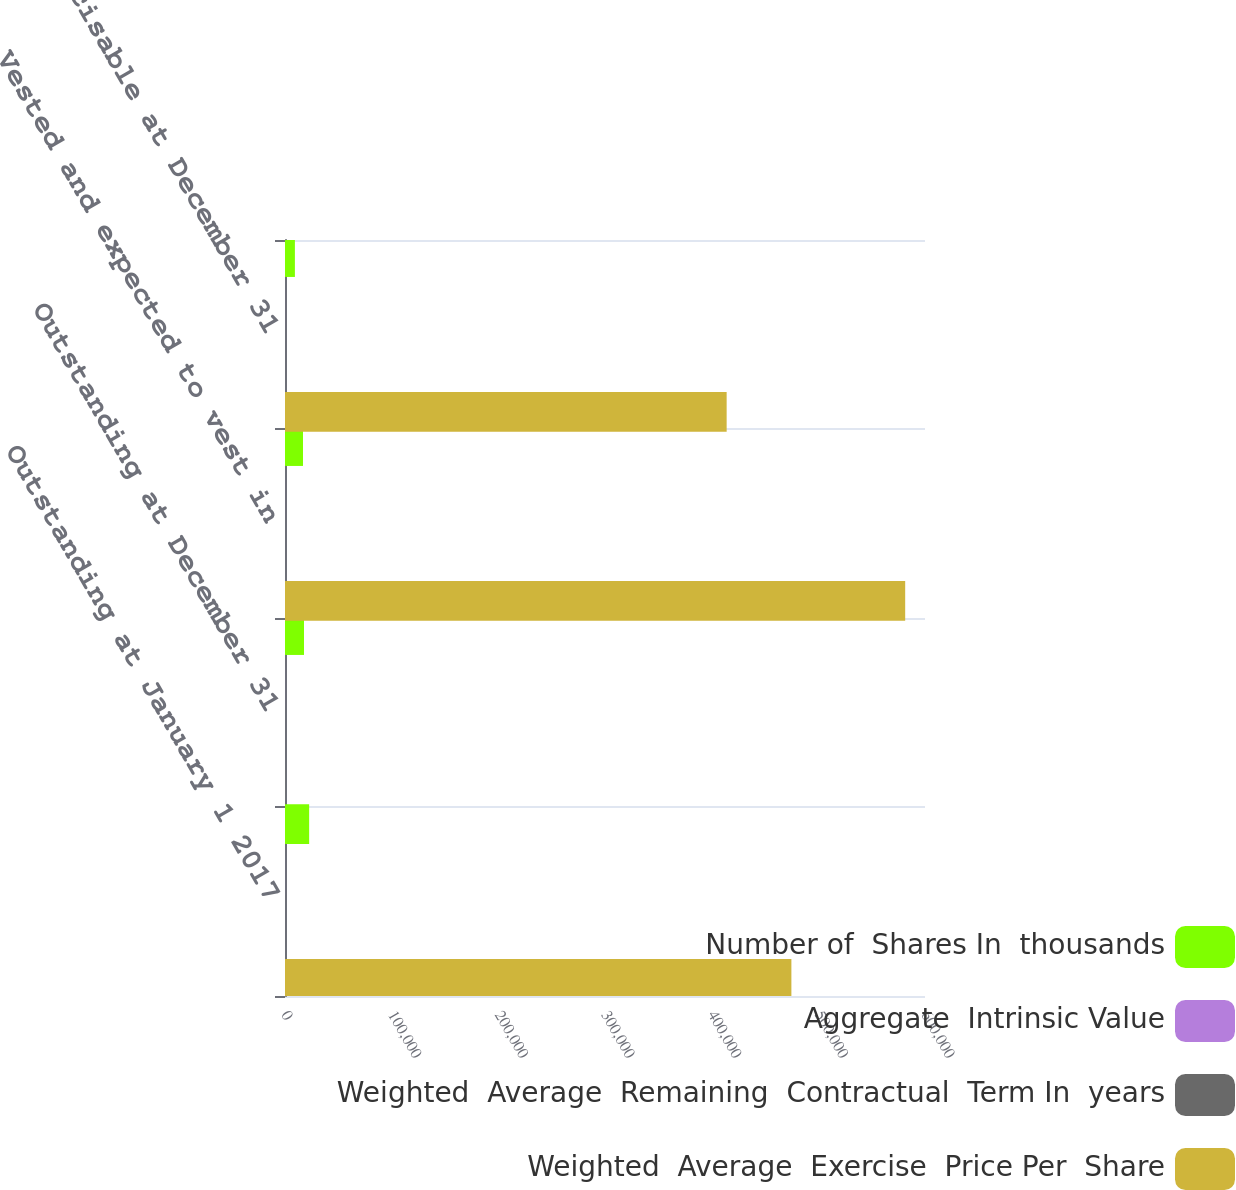Convert chart to OTSL. <chart><loc_0><loc_0><loc_500><loc_500><stacked_bar_chart><ecel><fcel>Outstanding at January 1 2017<fcel>Outstanding at December 31<fcel>Vested and expected to vest in<fcel>Exercisable at December 31<nl><fcel>Number of  Shares In  thousands<fcel>22643<fcel>17819<fcel>16863<fcel>9282<nl><fcel>Aggregate  Intrinsic Value<fcel>23.55<fcel>29.62<fcel>28.81<fcel>18.68<nl><fcel>Weighted  Average  Remaining  Contractual  Term In  years<fcel>5.8<fcel>6.1<fcel>6<fcel>4.4<nl><fcel>Weighted  Average  Exercise  Price Per  Share<fcel>474739<fcel>29.62<fcel>581425<fcel>414052<nl></chart> 